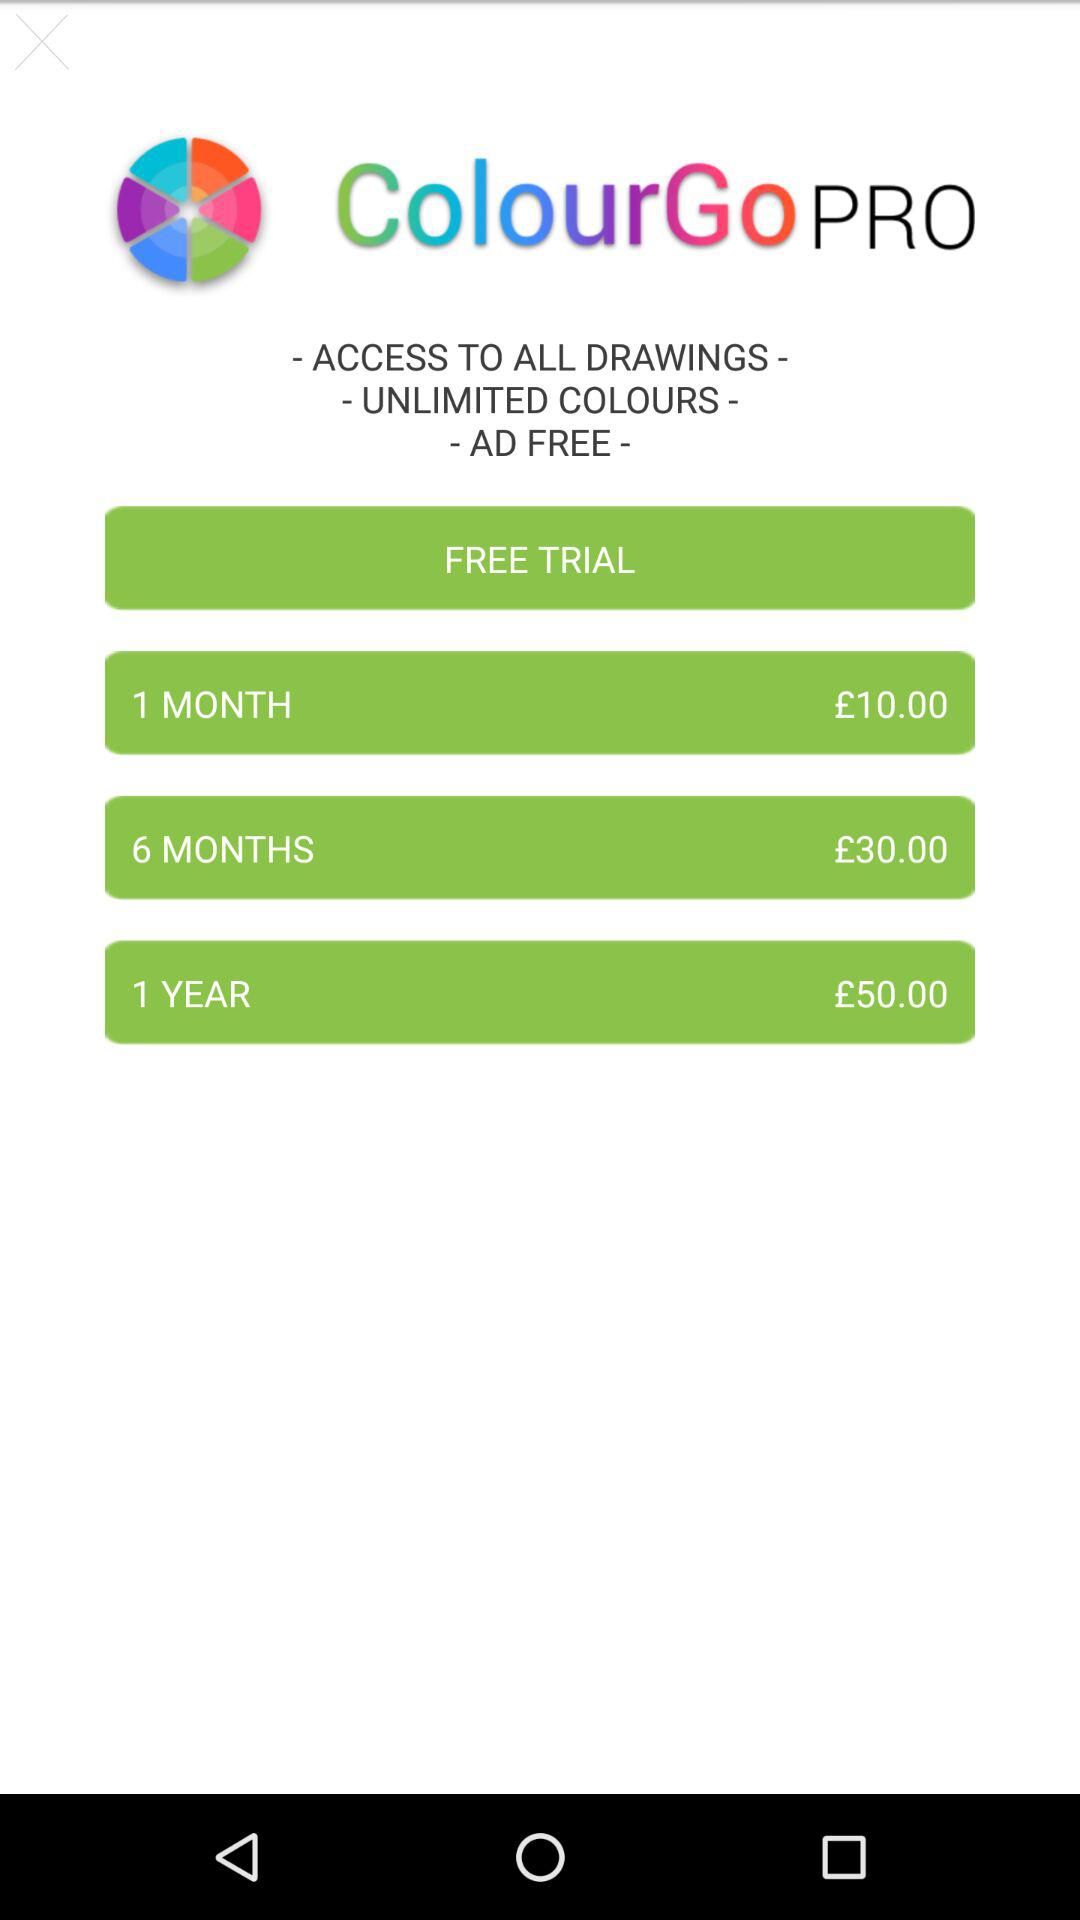How much more does the 1 year subscription cost than the 6 month subscription?
Answer the question using a single word or phrase. £20.00 